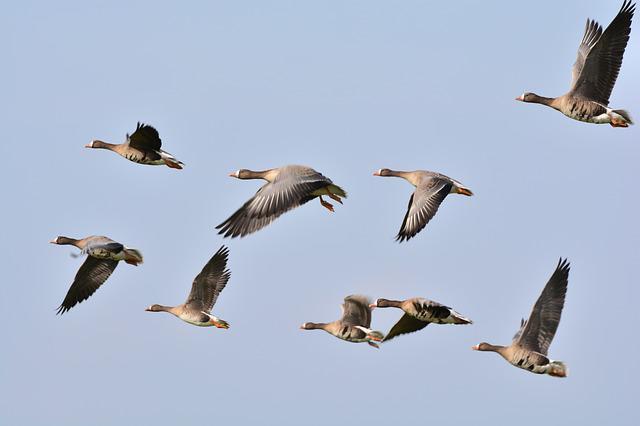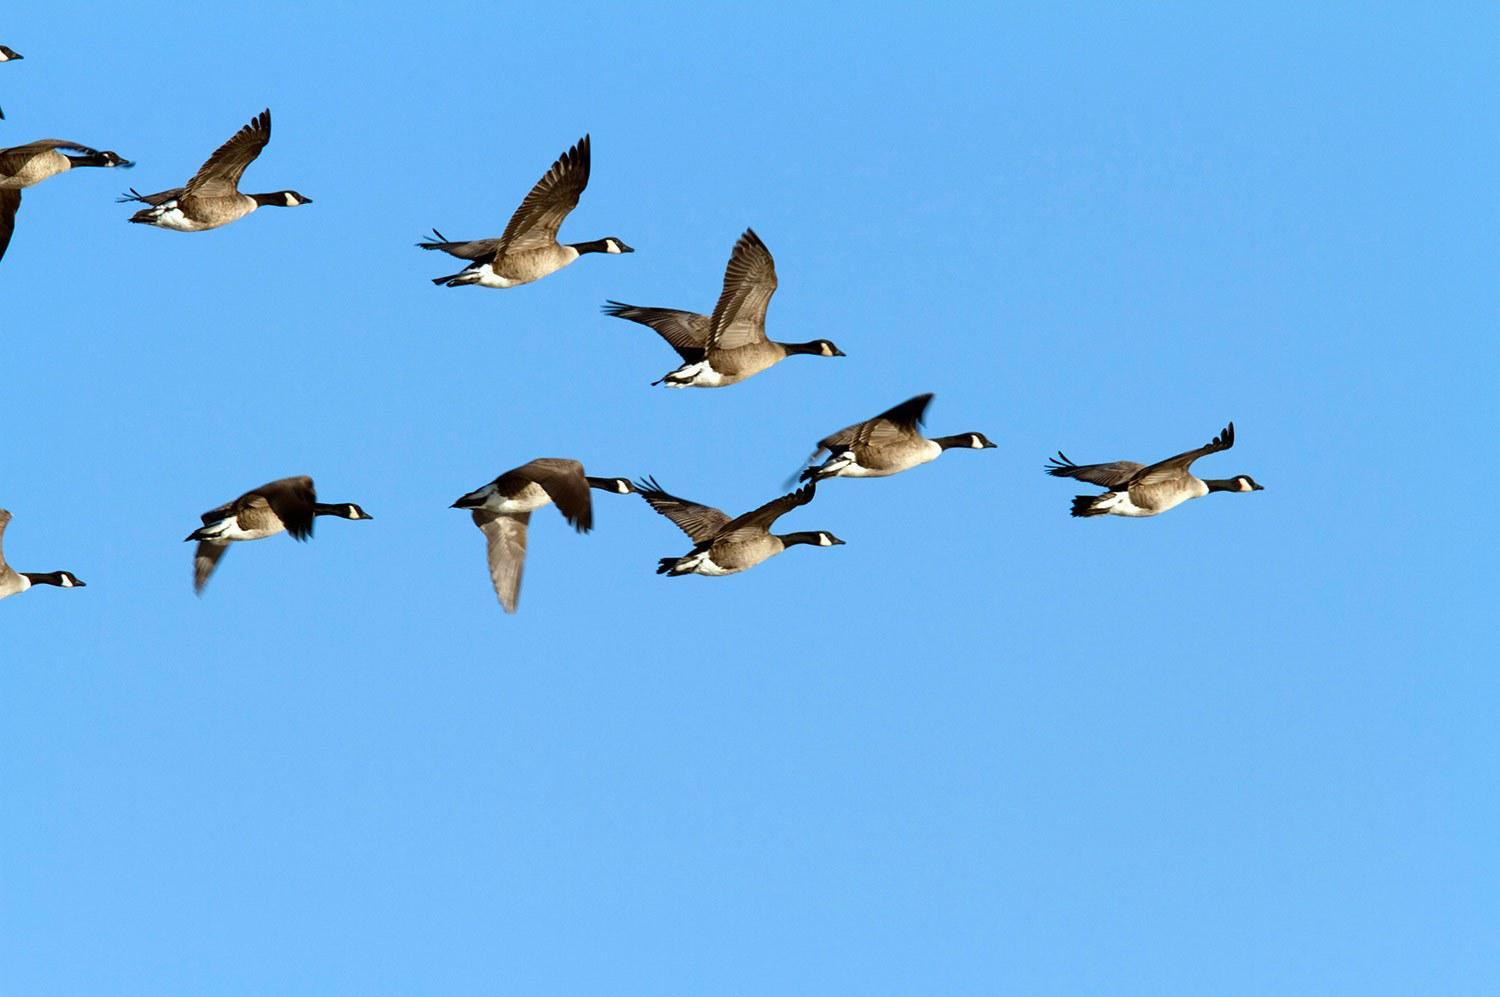The first image is the image on the left, the second image is the image on the right. Considering the images on both sides, is "The right image shows geese flying rightward in a V formation on a clear turquoise-blue sky." valid? Answer yes or no. Yes. 